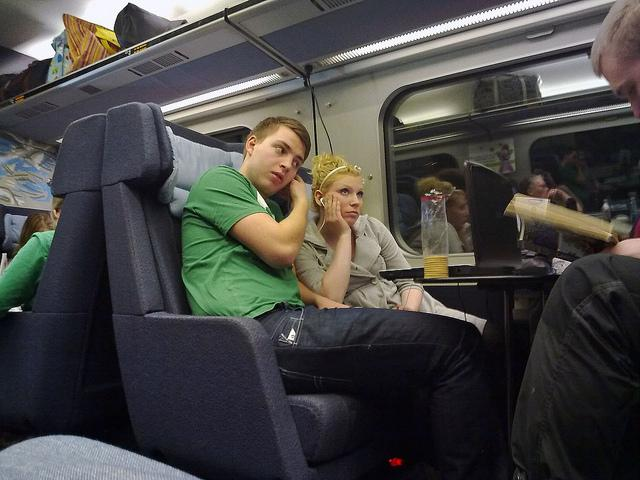What are the two young people doing with the headphones? sharing 